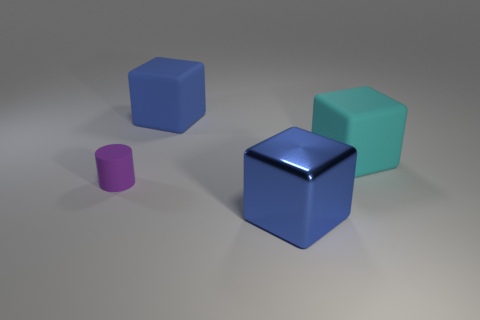What material is the other thing that is the same color as the shiny object?
Offer a terse response. Rubber. Is the tiny rubber cylinder the same color as the large metal object?
Provide a succinct answer. No. Are there any large purple things of the same shape as the small purple rubber object?
Your answer should be very brief. No. What number of blue objects are either small things or big metal objects?
Keep it short and to the point. 1. Is there a red matte object of the same size as the cylinder?
Your response must be concise. No. What number of cylinders are there?
Offer a terse response. 1. How many large things are gray matte balls or shiny cubes?
Offer a very short reply. 1. There is a matte thing that is left of the rubber cube to the left of the big matte cube to the right of the metal block; what color is it?
Offer a very short reply. Purple. How many other things are the same color as the big metallic block?
Offer a very short reply. 1. What number of rubber objects are tiny cylinders or large cubes?
Provide a succinct answer. 3. 